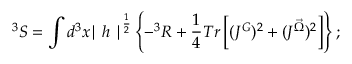Convert formula to latex. <formula><loc_0><loc_0><loc_500><loc_500>^ { 3 } S = \int d ^ { 3 } x { | h | } ^ { \frac { 1 } { 2 } } \left \{ - ^ { 3 } R + \frac { 1 } { 4 } T r \left [ ( J ^ { G } ) ^ { 2 } + ( J ^ { \vec { \Omega } } ) ^ { 2 } \right ] \right \} ;</formula> 